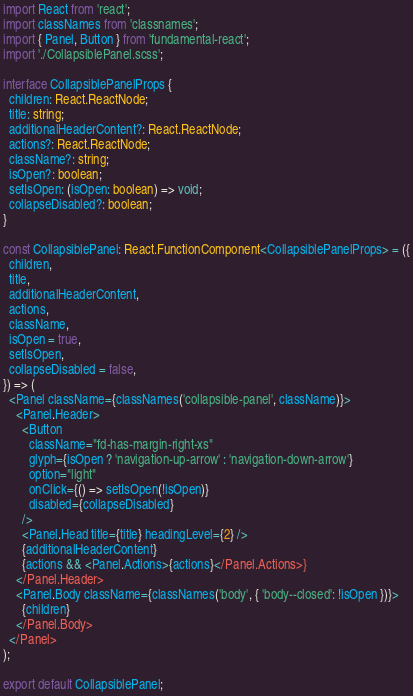<code> <loc_0><loc_0><loc_500><loc_500><_TypeScript_>import React from 'react';
import classNames from 'classnames';
import { Panel, Button } from 'fundamental-react';
import './CollapsiblePanel.scss';

interface CollapsiblePanelProps {
  children: React.ReactNode;
  title: string;
  additionalHeaderContent?: React.ReactNode;
  actions?: React.ReactNode;
  className?: string;
  isOpen?: boolean;
  setIsOpen: (isOpen: boolean) => void;
  collapseDisabled?: boolean;
}

const CollapsiblePanel: React.FunctionComponent<CollapsiblePanelProps> = ({
  children,
  title,
  additionalHeaderContent,
  actions,
  className,
  isOpen = true,
  setIsOpen,
  collapseDisabled = false,
}) => (
  <Panel className={classNames('collapsible-panel', className)}>
    <Panel.Header>
      <Button
        className="fd-has-margin-right-xs"
        glyph={isOpen ? 'navigation-up-arrow' : 'navigation-down-arrow'}
        option="light"
        onClick={() => setIsOpen(!isOpen)}
        disabled={collapseDisabled}
      />
      <Panel.Head title={title} headingLevel={2} />
      {additionalHeaderContent}
      {actions && <Panel.Actions>{actions}</Panel.Actions>}
    </Panel.Header>
    <Panel.Body className={classNames('body', { 'body--closed': !isOpen })}>
      {children}
    </Panel.Body>
  </Panel>
);

export default CollapsiblePanel;
</code> 